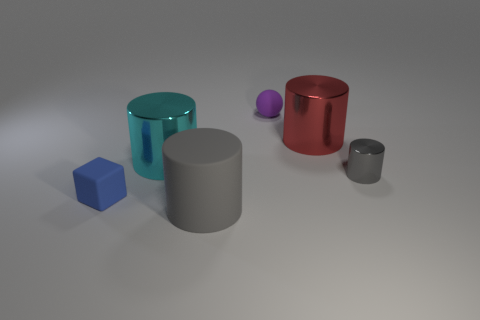Subtract all red cylinders. How many cylinders are left? 3 Add 1 small purple rubber cubes. How many objects exist? 7 Subtract all yellow balls. How many gray cylinders are left? 2 Subtract 1 cylinders. How many cylinders are left? 3 Subtract all gray cylinders. How many cylinders are left? 2 Subtract all spheres. How many objects are left? 5 Subtract all green cubes. Subtract all gray cylinders. How many cubes are left? 1 Subtract all large blue matte spheres. Subtract all blue blocks. How many objects are left? 5 Add 1 small rubber blocks. How many small rubber blocks are left? 2 Add 2 purple things. How many purple things exist? 3 